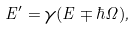<formula> <loc_0><loc_0><loc_500><loc_500>E ^ { \prime } = \gamma ( E \mp \hbar { \Omega } ) ,</formula> 